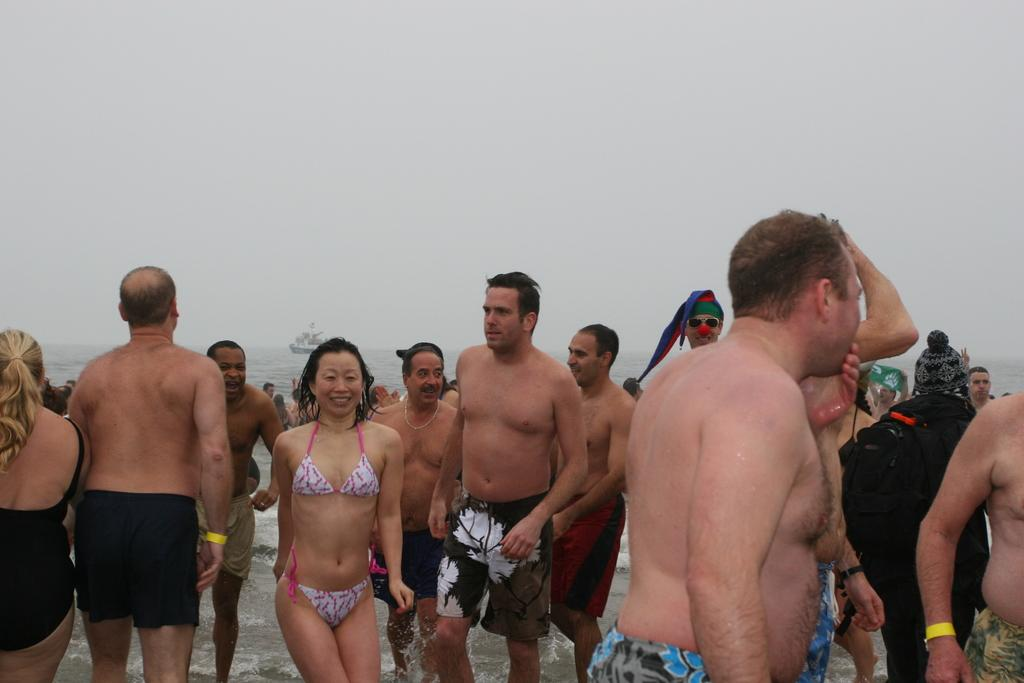Who or what can be seen in the image? There are people in the image. What is visible in the background of the image? There is water visible in the background of the image. What is located on the water in the image? There is a ship on the water. What is visible at the top of the image? The sky is visible at the top of the image. What type of bells can be heard ringing in the image? There are no bells present in the image, and therefore no sound can be heard. What kind of property is visible in the image? The image does not show any property; it features people, water, a ship, and the sky. 